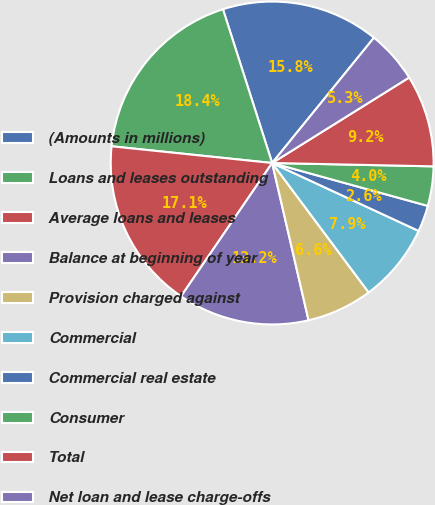Convert chart to OTSL. <chart><loc_0><loc_0><loc_500><loc_500><pie_chart><fcel>(Amounts in millions)<fcel>Loans and leases outstanding<fcel>Average loans and leases<fcel>Balance at beginning of year<fcel>Provision charged against<fcel>Commercial<fcel>Commercial real estate<fcel>Consumer<fcel>Total<fcel>Net loan and lease charge-offs<nl><fcel>15.79%<fcel>18.42%<fcel>17.11%<fcel>13.16%<fcel>6.58%<fcel>7.89%<fcel>2.63%<fcel>3.95%<fcel>9.21%<fcel>5.26%<nl></chart> 